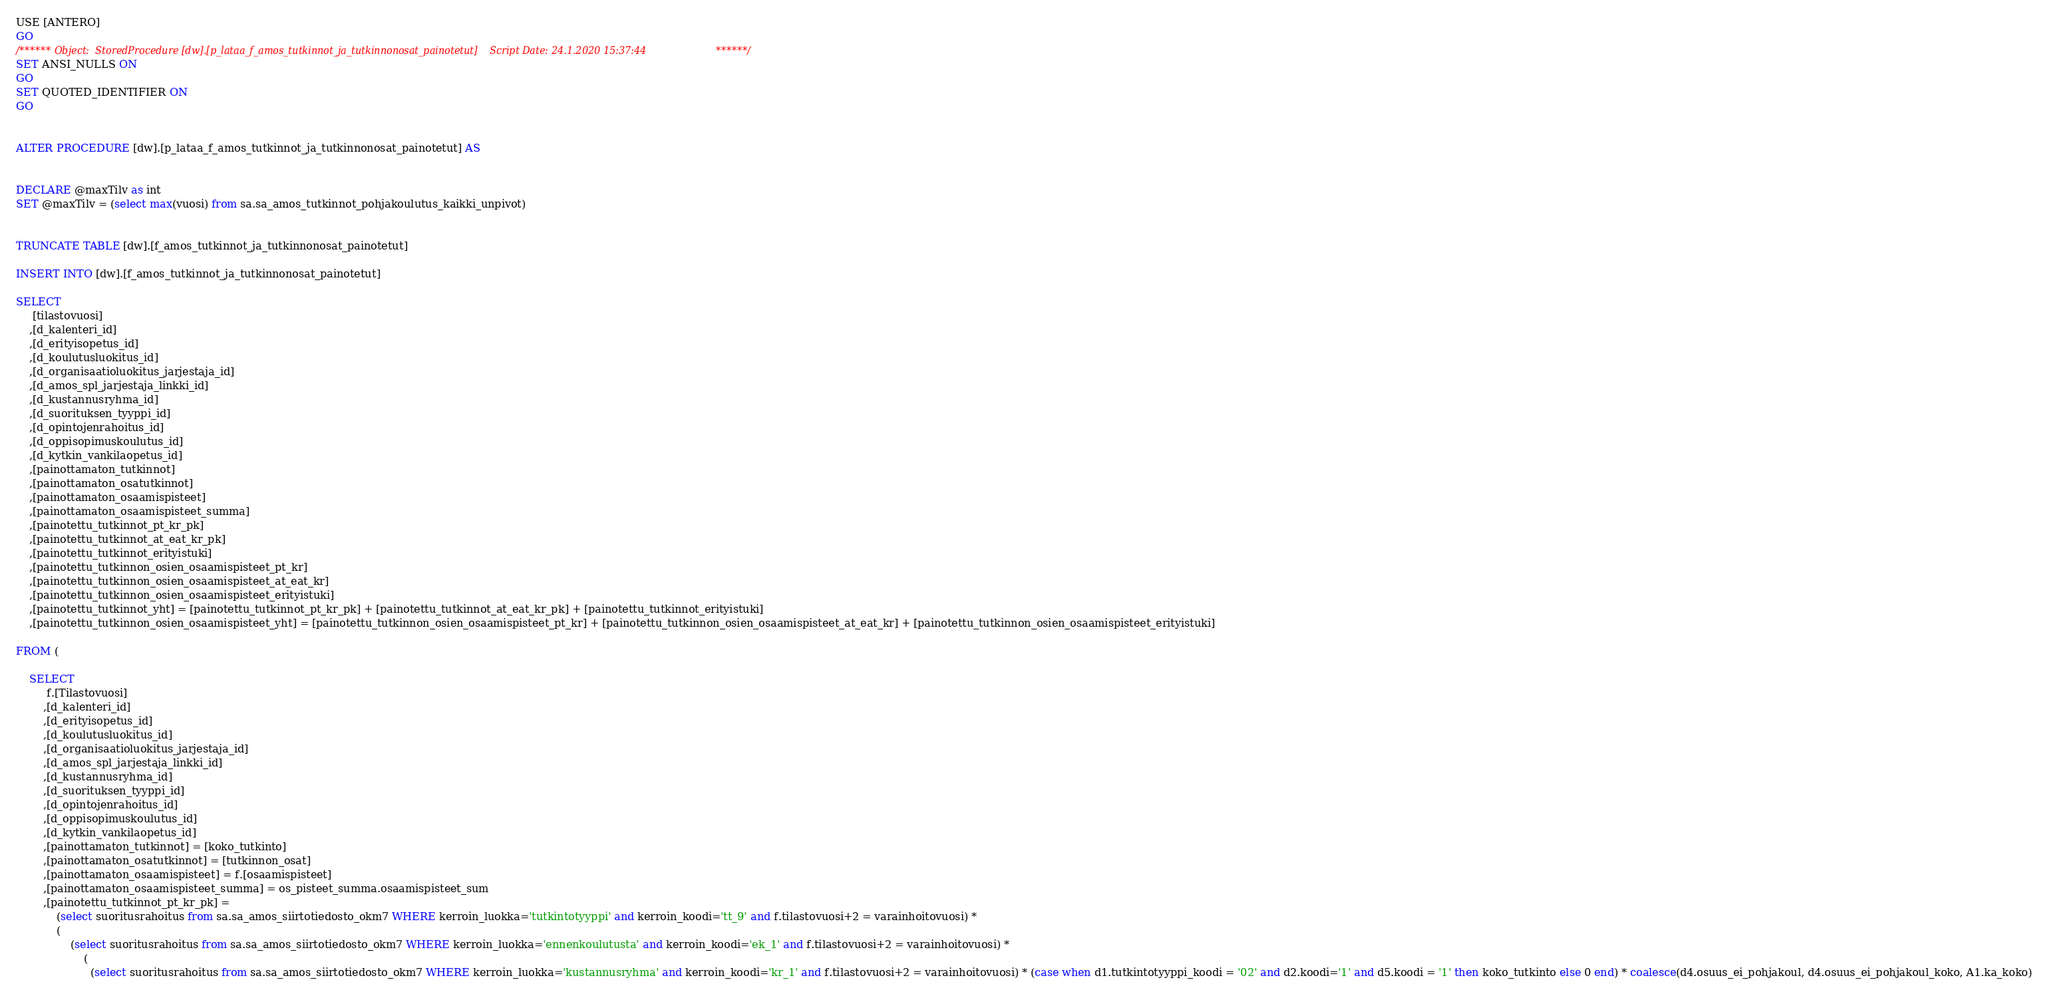<code> <loc_0><loc_0><loc_500><loc_500><_SQL_>USE [ANTERO]
GO
/****** Object:  StoredProcedure [dw].[p_lataa_f_amos_tutkinnot_ja_tutkinnonosat_painotetut]    Script Date: 24.1.2020 15:37:44 ******/
SET ANSI_NULLS ON
GO
SET QUOTED_IDENTIFIER ON
GO


ALTER PROCEDURE [dw].[p_lataa_f_amos_tutkinnot_ja_tutkinnonosat_painotetut] AS


DECLARE @maxTilv as int
SET @maxTilv = (select max(vuosi) from sa.sa_amos_tutkinnot_pohjakoulutus_kaikki_unpivot)


TRUNCATE TABLE [dw].[f_amos_tutkinnot_ja_tutkinnonosat_painotetut]

INSERT INTO [dw].[f_amos_tutkinnot_ja_tutkinnonosat_painotetut]

SELECT  
	 [tilastovuosi]
	,[d_kalenteri_id]
	,[d_erityisopetus_id]
	,[d_koulutusluokitus_id]
	,[d_organisaatioluokitus_jarjestaja_id]
	,[d_amos_spl_jarjestaja_linkki_id]
	,[d_kustannusryhma_id]
	,[d_suorituksen_tyyppi_id]
	,[d_opintojenrahoitus_id]
	,[d_oppisopimuskoulutus_id]
	,[d_kytkin_vankilaopetus_id]
	,[painottamaton_tutkinnot]
	,[painottamaton_osatutkinnot] 
	,[painottamaton_osaamispisteet]
	,[painottamaton_osaamispisteet_summa]
	,[painotettu_tutkinnot_pt_kr_pk]
	,[painotettu_tutkinnot_at_eat_kr_pk]
	,[painotettu_tutkinnot_erityistuki]
	,[painotettu_tutkinnon_osien_osaamispisteet_pt_kr]
	,[painotettu_tutkinnon_osien_osaamispisteet_at_eat_kr]
	,[painotettu_tutkinnon_osien_osaamispisteet_erityistuki]
	,[painotettu_tutkinnot_yht] = [painotettu_tutkinnot_pt_kr_pk] + [painotettu_tutkinnot_at_eat_kr_pk] + [painotettu_tutkinnot_erityistuki]
	,[painotettu_tutkinnon_osien_osaamispisteet_yht] = [painotettu_tutkinnon_osien_osaamispisteet_pt_kr] + [painotettu_tutkinnon_osien_osaamispisteet_at_eat_kr] + [painotettu_tutkinnon_osien_osaamispisteet_erityistuki]

FROM (

	SELECT
		 f.[Tilastovuosi]
		,[d_kalenteri_id]
		,[d_erityisopetus_id]
		,[d_koulutusluokitus_id]
		,[d_organisaatioluokitus_jarjestaja_id]
		,[d_amos_spl_jarjestaja_linkki_id]
		,[d_kustannusryhma_id]
		,[d_suorituksen_tyyppi_id]
		,[d_opintojenrahoitus_id]
		,[d_oppisopimuskoulutus_id]
		,[d_kytkin_vankilaopetus_id]
		,[painottamaton_tutkinnot] = [koko_tutkinto]
		,[painottamaton_osatutkinnot] = [tutkinnon_osat]
		,[painottamaton_osaamispisteet] = f.[osaamispisteet]
		,[painottamaton_osaamispisteet_summa] = os_pisteet_summa.osaamispisteet_sum
		,[painotettu_tutkinnot_pt_kr_pk] = 
			(select suoritusrahoitus from sa.sa_amos_siirtotiedosto_okm7 WHERE kerroin_luokka='tutkintotyyppi' and kerroin_koodi='tt_9' and f.tilastovuosi+2 = varainhoitovuosi) *
			(
				(select suoritusrahoitus from sa.sa_amos_siirtotiedosto_okm7 WHERE kerroin_luokka='ennenkoulutusta' and kerroin_koodi='ek_1' and f.tilastovuosi+2 = varainhoitovuosi) *
					(
					  (select suoritusrahoitus from sa.sa_amos_siirtotiedosto_okm7 WHERE kerroin_luokka='kustannusryhma' and kerroin_koodi='kr_1' and f.tilastovuosi+2 = varainhoitovuosi) * (case when d1.tutkintotyyppi_koodi = '02' and d2.koodi='1' and d5.koodi = '1' then koko_tutkinto else 0 end) * coalesce(d4.osuus_ei_pohjakoul, d4.osuus_ei_pohjakoul_koko, A1.ka_koko)</code> 